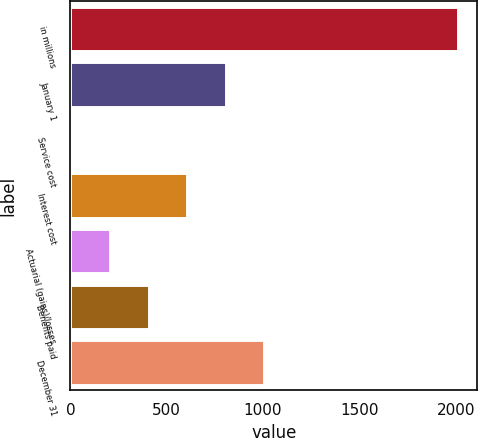Convert chart to OTSL. <chart><loc_0><loc_0><loc_500><loc_500><bar_chart><fcel>in millions<fcel>January 1<fcel>Service cost<fcel>Interest cost<fcel>Actuarial (gains)/losses<fcel>Benefits paid<fcel>December 31<nl><fcel>2010<fcel>806.46<fcel>4.1<fcel>605.87<fcel>204.69<fcel>405.28<fcel>1007.05<nl></chart> 